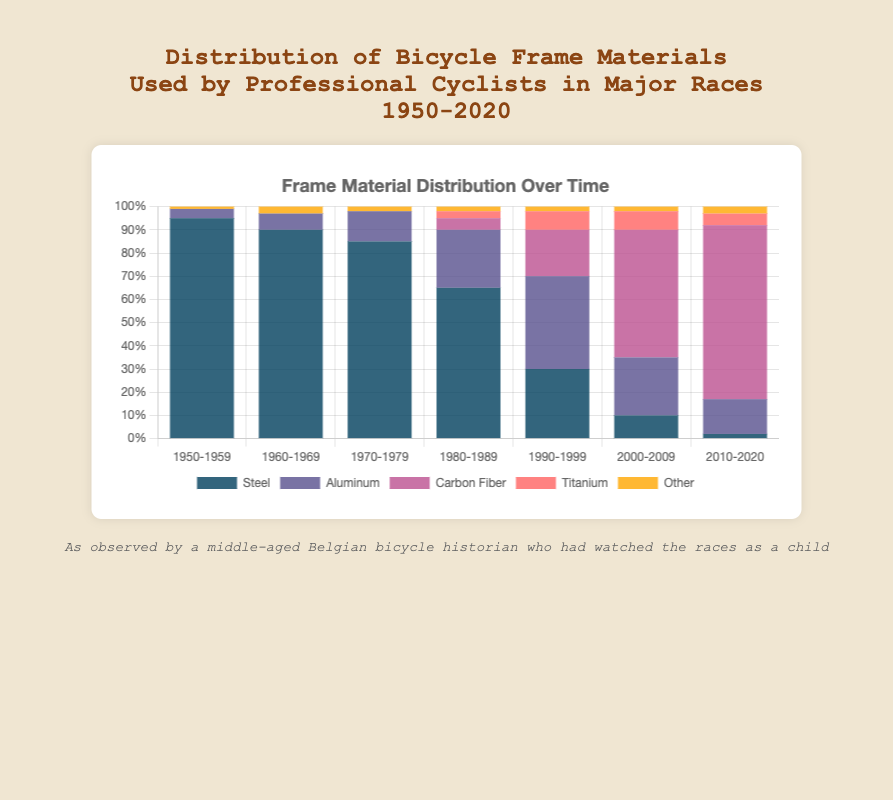Which decade saw the highest percentage of steel frames? The highest percentage of steel frames can be found by looking for the tallest blue bar across the decades. The bar for steel frames in the 1950-1959 range is the tallest at 95%.
Answer: 1950-1959 What is the total percentage of non-steel materials used in the 1990-1999 decade? Summing up the percentages of aluminum, carbon fiber, titanium, and other materials in the 1990-1999 decade: 40% (aluminum) + 20% (carbon fiber) + 8% (titanium) + 2% (other) = 70%.
Answer: 70% Between 1980-1989 and 2010-2020, did the use of carbon fiber frames increase? Compare the percentages of carbon fiber frames in both decades. For 1980-1989, it is 5%, and for 2010-2020, it is 75%.
Answer: Yes By how much did the percentage of aluminum frames change from 1970-1979 to 1980-1989? The percentage of aluminum frames in 1970-1979 was 13%, and in 1980-1989, it was 25%. The change is 25% - 13% = 12%.
Answer: 12% Which material had the lowest percentage usage in the 2000-2009 decade? Look at the percentages for each material in the 2000-2009 decade and find the smallest one. The lowest is 'Other' at 2%.
Answer: Other What is the average percentage usage of titanium frames from 1990 to 2020? The percentage usage of titanium frames is 8% (1990-1999), 8% (2000-2009), and 5% (2010-2020). The average is (8% + 8% + 5%)/3 = 7%.
Answer: 7% Which decade had the highest diversity in frame materials based on the visual distribution of bars? Higher diversity would be indicated by smaller gaps between the different colored bars within a decade. The 1990-1999 decade appears to have the most diverse distribution with a significant presence of all materials.
Answer: 1990-1999 Comparing steel and carbon fiber frame usage in 2010-2020, which is higher and by what percentage? The steel frame usage is 2%, and carbon fiber frame usage is 75% in 2010-2020. The difference is 75% - 2% = 73%.
Answer: Carbon fiber, 73% What trends can be observed for steel frame usage over the decades? Observing the heights of the blue bars from left to right, the percentage of steel frames has been steadily decreasing from 1950-1959 (95%) to 2010-2020 (2%).
Answer: Decreasing How much did the use of carbon fiber frames increase from 1980-1989 to 2000-2009? The percentage usage of carbon fiber frames increased from 5% in 1980-1989 to 55% in 2000-2009. The increase is 55% - 5% = 50%.
Answer: 50% 